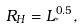<formula> <loc_0><loc_0><loc_500><loc_500>R _ { H } = L _ { ^ { * } } ^ { 0 . 5 } ,</formula> 